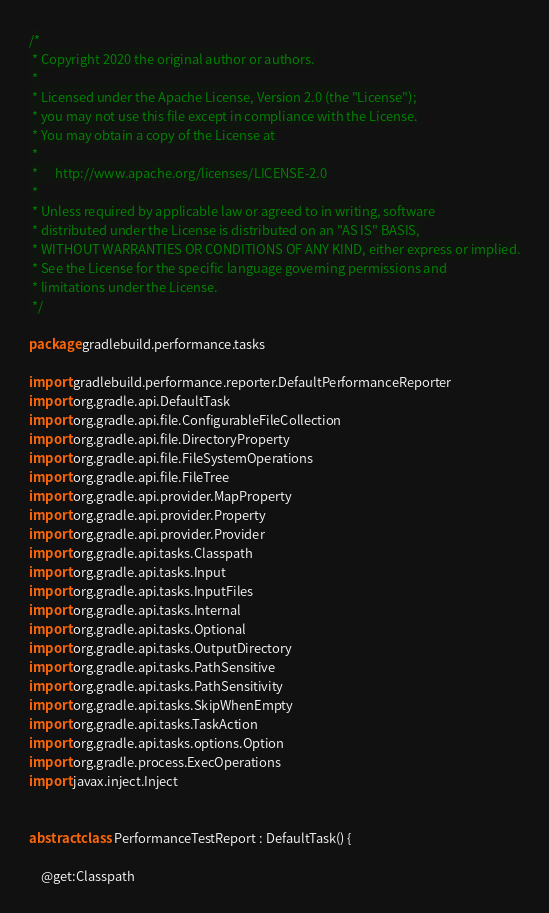Convert code to text. <code><loc_0><loc_0><loc_500><loc_500><_Kotlin_>/*
 * Copyright 2020 the original author or authors.
 *
 * Licensed under the Apache License, Version 2.0 (the "License");
 * you may not use this file except in compliance with the License.
 * You may obtain a copy of the License at
 *
 *      http://www.apache.org/licenses/LICENSE-2.0
 *
 * Unless required by applicable law or agreed to in writing, software
 * distributed under the License is distributed on an "AS IS" BASIS,
 * WITHOUT WARRANTIES OR CONDITIONS OF ANY KIND, either express or implied.
 * See the License for the specific language governing permissions and
 * limitations under the License.
 */

package gradlebuild.performance.tasks

import gradlebuild.performance.reporter.DefaultPerformanceReporter
import org.gradle.api.DefaultTask
import org.gradle.api.file.ConfigurableFileCollection
import org.gradle.api.file.DirectoryProperty
import org.gradle.api.file.FileSystemOperations
import org.gradle.api.file.FileTree
import org.gradle.api.provider.MapProperty
import org.gradle.api.provider.Property
import org.gradle.api.provider.Provider
import org.gradle.api.tasks.Classpath
import org.gradle.api.tasks.Input
import org.gradle.api.tasks.InputFiles
import org.gradle.api.tasks.Internal
import org.gradle.api.tasks.Optional
import org.gradle.api.tasks.OutputDirectory
import org.gradle.api.tasks.PathSensitive
import org.gradle.api.tasks.PathSensitivity
import org.gradle.api.tasks.SkipWhenEmpty
import org.gradle.api.tasks.TaskAction
import org.gradle.api.tasks.options.Option
import org.gradle.process.ExecOperations
import javax.inject.Inject


abstract class PerformanceTestReport : DefaultTask() {

    @get:Classpath</code> 